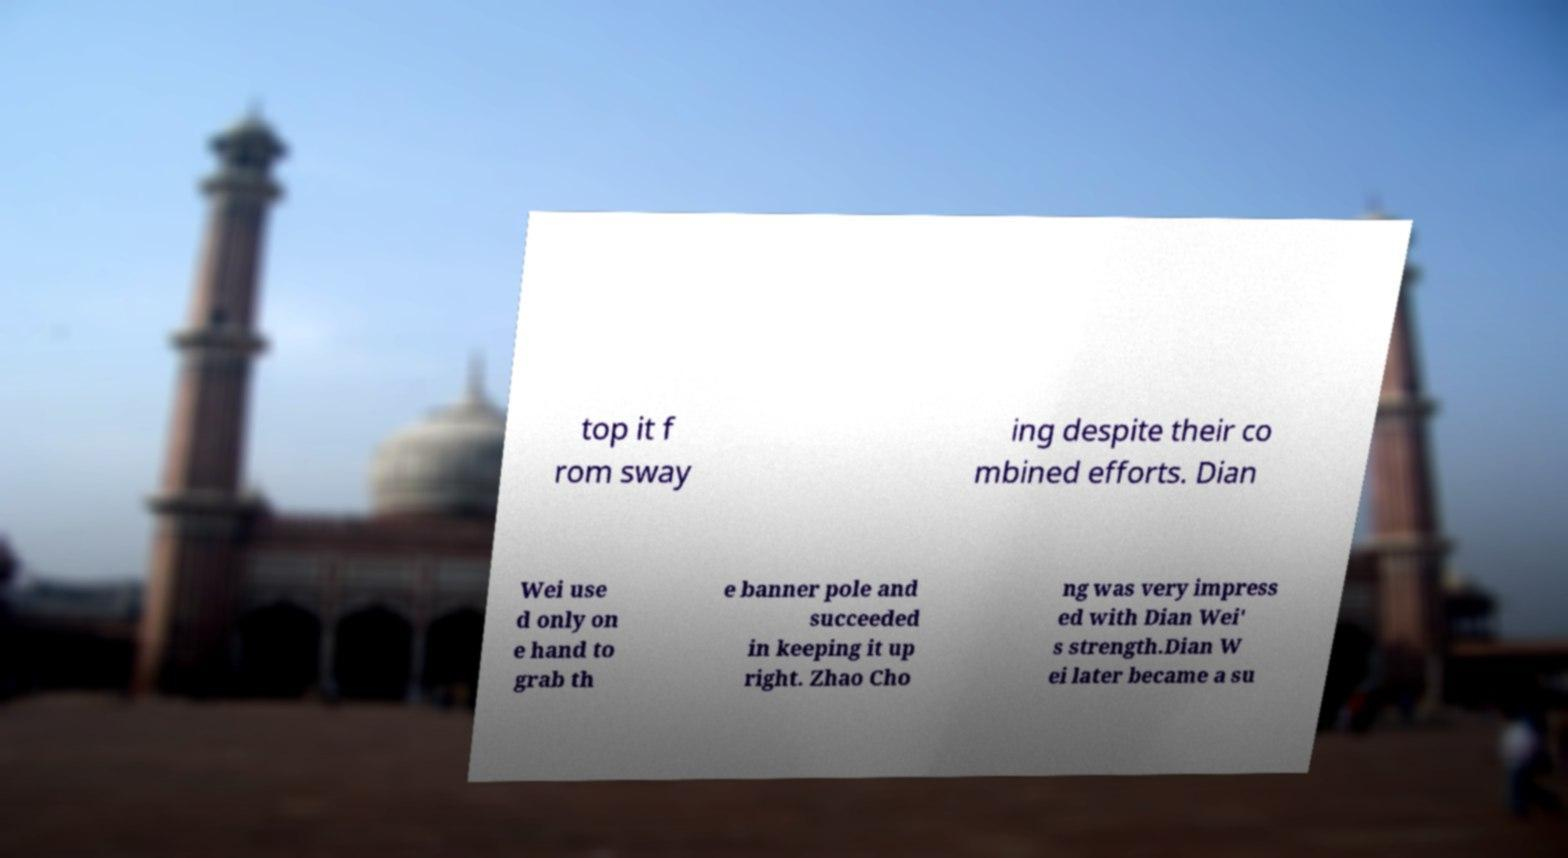Could you assist in decoding the text presented in this image and type it out clearly? top it f rom sway ing despite their co mbined efforts. Dian Wei use d only on e hand to grab th e banner pole and succeeded in keeping it up right. Zhao Cho ng was very impress ed with Dian Wei' s strength.Dian W ei later became a su 